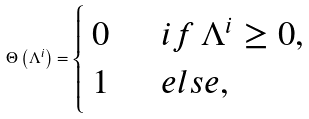<formula> <loc_0><loc_0><loc_500><loc_500>\Theta \left ( \Lambda ^ { i } \right ) = \begin{cases} \begin{array} { l } 0 \\ 1 \end{array} & \begin{array} { l } i f \, \Lambda ^ { i } \geq 0 , \\ e l s e , \end{array} \end{cases}</formula> 